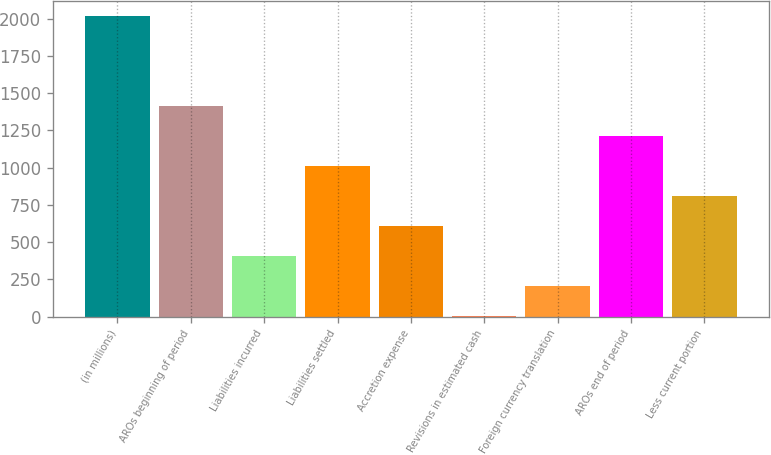Convert chart to OTSL. <chart><loc_0><loc_0><loc_500><loc_500><bar_chart><fcel>(in millions)<fcel>AROs beginning of period<fcel>Liabilities incurred<fcel>Liabilities settled<fcel>Accretion expense<fcel>Revisions in estimated cash<fcel>Foreign currency translation<fcel>AROs end of period<fcel>Less current portion<nl><fcel>2015<fcel>1412.57<fcel>408.52<fcel>1010.95<fcel>609.33<fcel>6.9<fcel>207.71<fcel>1211.76<fcel>810.14<nl></chart> 